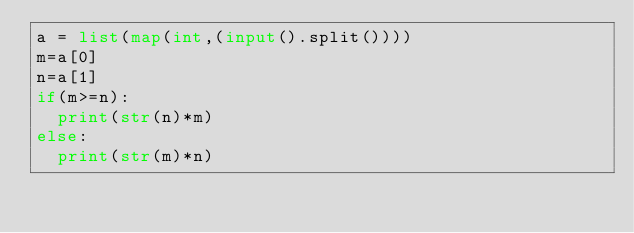Convert code to text. <code><loc_0><loc_0><loc_500><loc_500><_Python_>a = list(map(int,(input().split())))
m=a[0]
n=a[1]
if(m>=n):
	print(str(n)*m)
else:
	print(str(m)*n)
</code> 